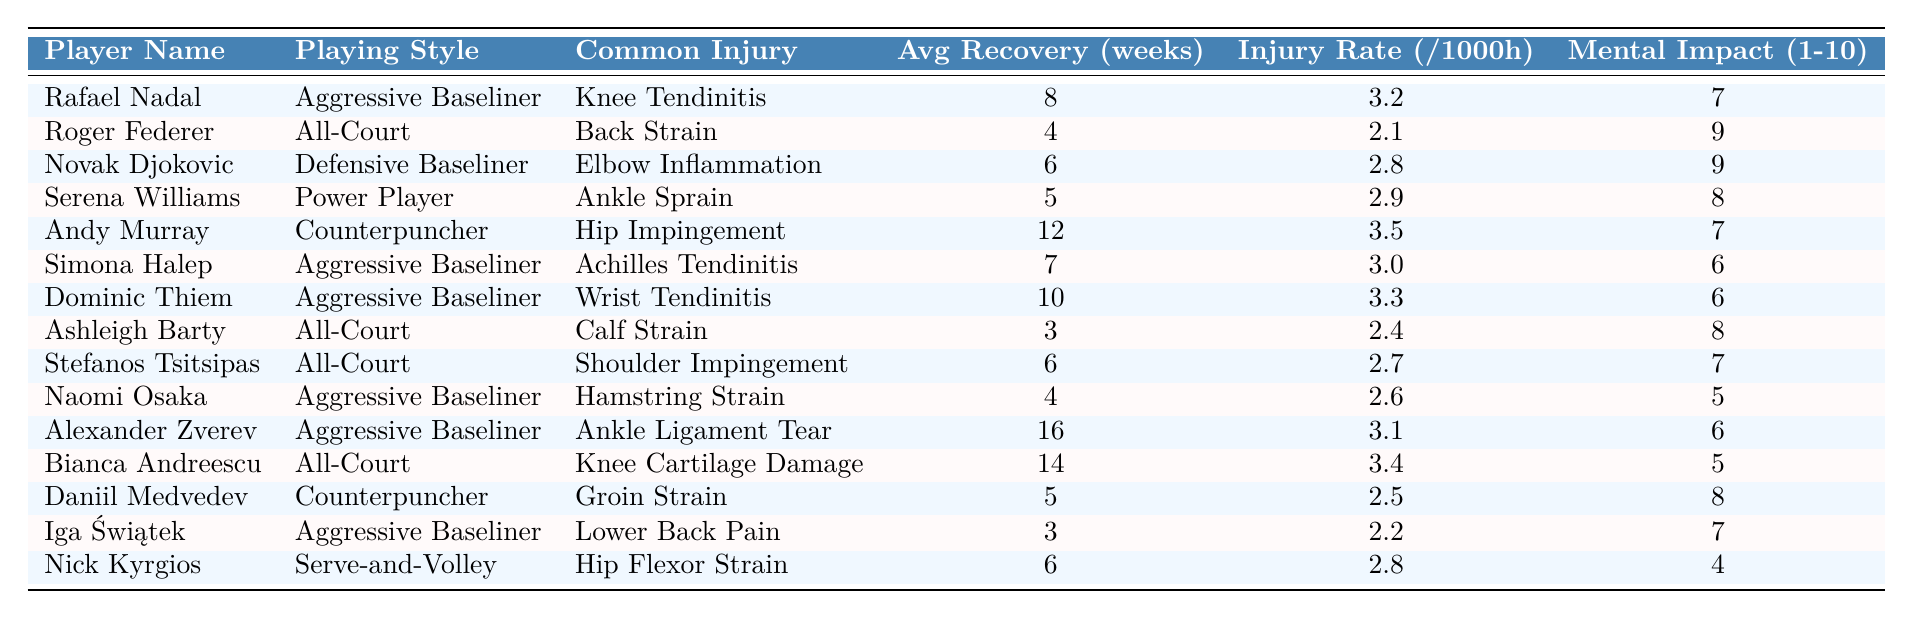What is the common injury for Rafael Nadal? According to the table, Rafael Nadal's common injury is listed as Knee Tendinitis.
Answer: Knee Tendinitis How many weeks of recovery does Serena Williams need on average? The table indicates that Serena Williams has an average recovery time of 5 weeks.
Answer: 5 weeks Who has the highest average recovery time? The highest average recovery time in the table is 16 weeks for Alexander Zverev.
Answer: 16 weeks What is the injury rate for Roger Federer? Roger Federer's injury rate, as shown in the table, is 2.1 per 1000 hours.
Answer: 2.1 per 1000 hours Do players with an aggressive baseline style have a higher mental impact score on average than those with an all-court style? The average mental impact score for Aggressive Baseliners (7.6) is higher than for All-Court players (8.0) when calculated from the table values. Thus, they do not.
Answer: No What is the difference in average recovery time between aggressive baseliners and power players? The average recovery time for Aggressive Baseliners is (8 + 7 + 10 + 4 + 16 + 3)/6 = 8 weeks, and for Power Players, it is 5 weeks, resulting in a difference of 3 weeks.
Answer: 3 weeks Is there a player with a mental impact score of 10 in the table? Checking the table, no player has a mental impact score of 10; the maximum is 9 for Roger Federer and Novak Djokovic.
Answer: No How many players have common injuries related to the knee? The table lists two players with knee injuries, Rafael Nadal (Knee Tendinitis) and Bianca Andreescu (Knee Cartilage Damage).
Answer: 2 players What is the total recovery time of all players listed in the table? Summing the average recovery times: 8 + 4 + 6 + 5 + 12 + 7 + 10 + 3 + 6 + 4 + 16 + 14 + 5 + 3 + 6 =  91 weeks.
Answer: 91 weeks Which playing style has the highest injury rate? Comparing the injury rates, Aggressive Baseliners have an injury rate of (3.2 + 3.0 + 3.3 + 2.6 + 3.1)/5 = 3.04 per 1000 hours, while the highest is for Andy Murray (Counterpuncher) at 3.5 per 1000 hours.
Answer: Counterpuncher 